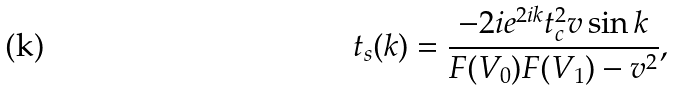<formula> <loc_0><loc_0><loc_500><loc_500>t _ { s } ( k ) = \frac { - 2 i e ^ { 2 i k } t _ { c } ^ { 2 } v \sin k } { F ( V _ { 0 } ) F ( V _ { 1 } ) - v ^ { 2 } } ,</formula> 